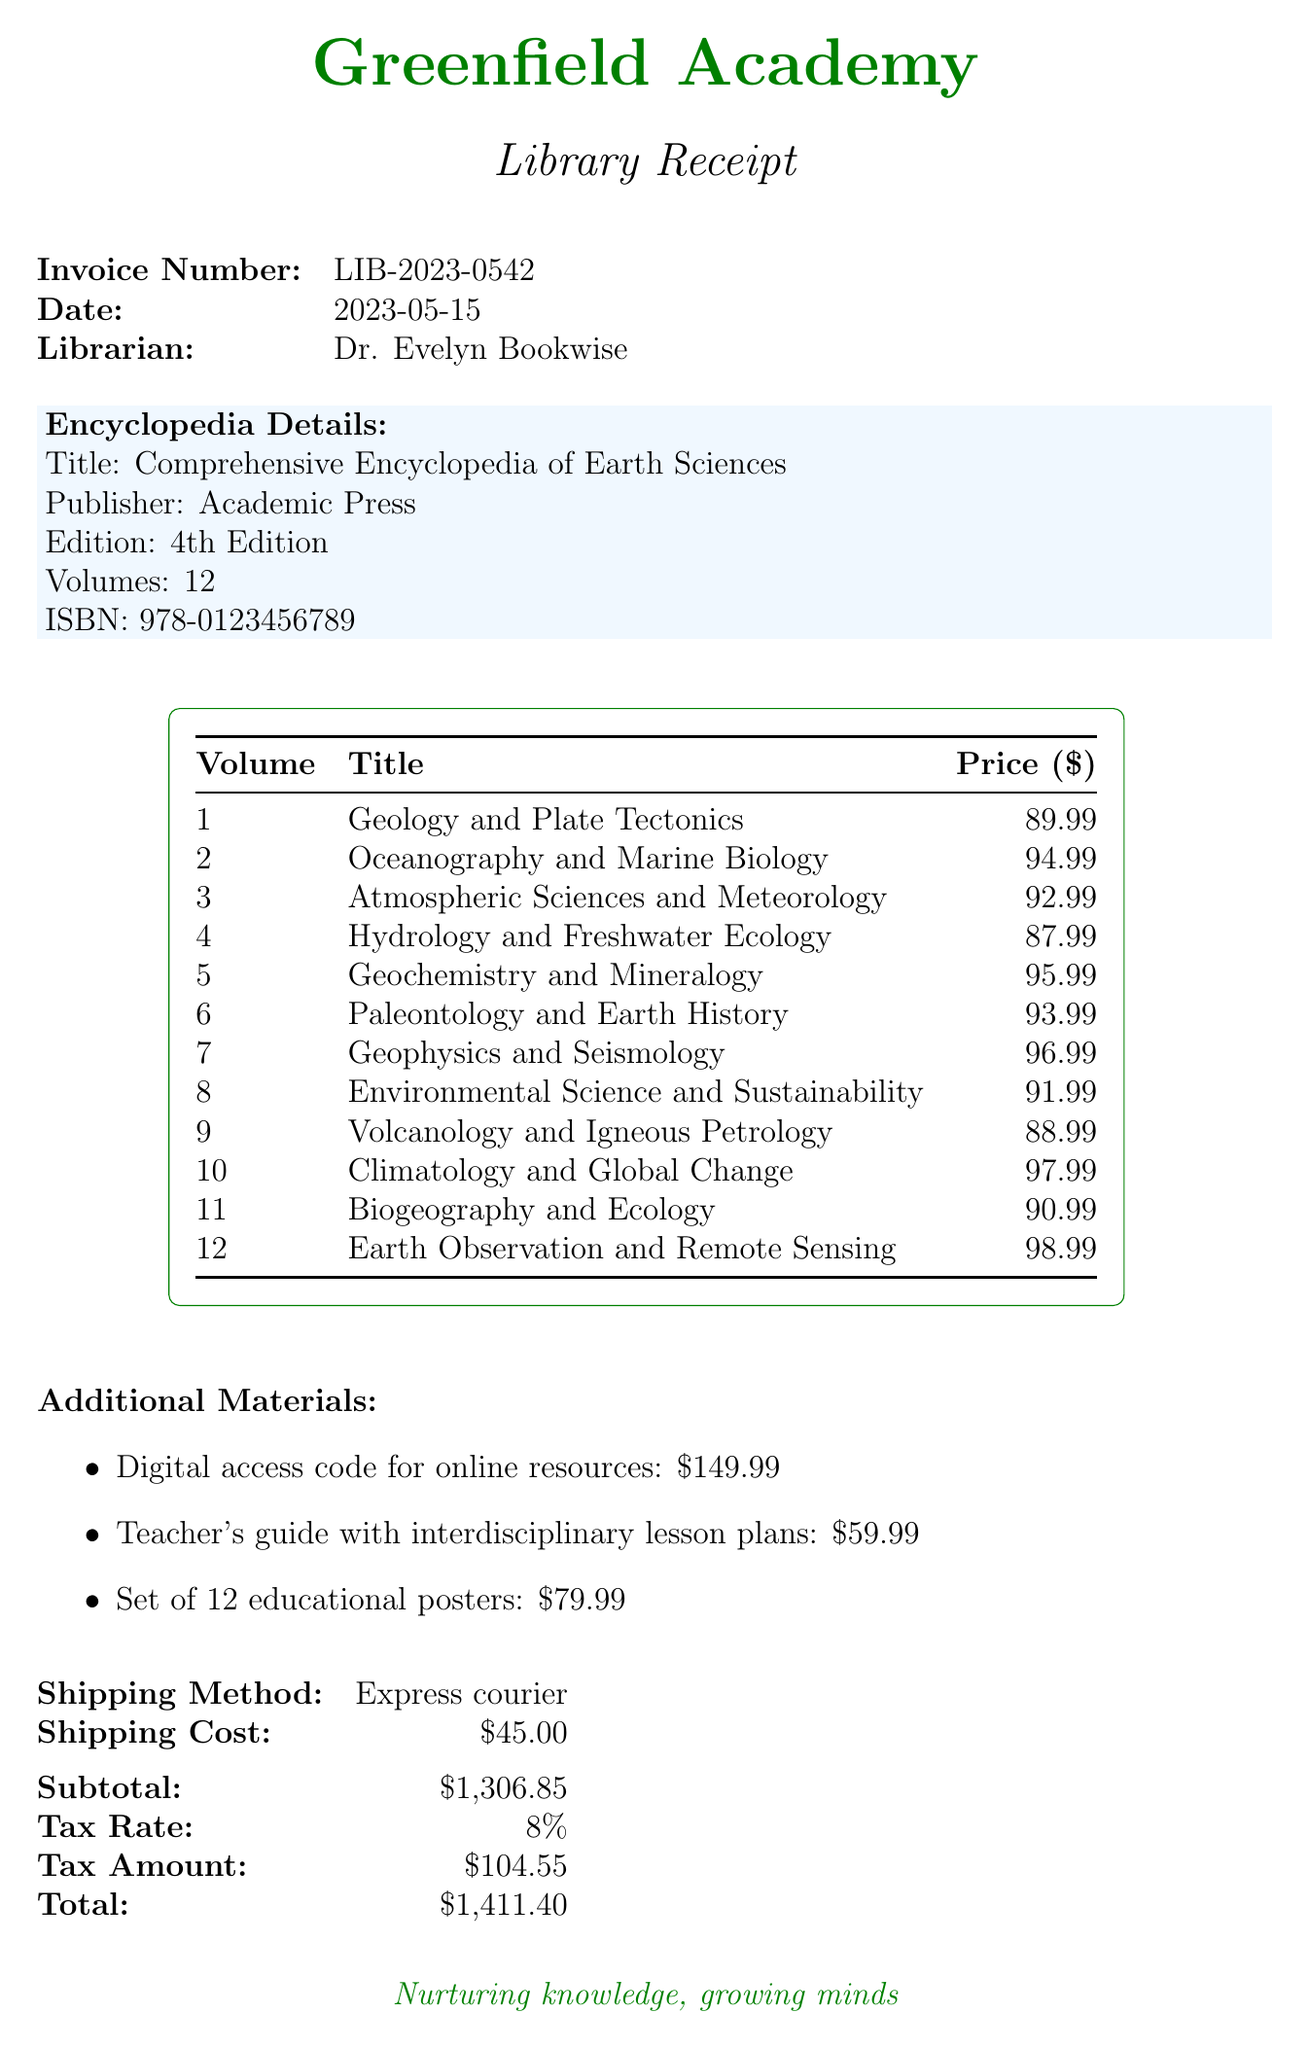what is the invoice number? The invoice number is listed at the top of the document.
Answer: LIB-2023-0542 what is the date of the invoice? The date is provided below the invoice number.
Answer: 2023-05-15 who is the librarian? The librarian's name appears in the receipt under "Librarian."
Answer: Dr. Evelyn Bookwise how many volumes are in the encyclopedia? The number of volumes is stated in the encyclopedia details section.
Answer: 12 what is the total amount due? The total amount is calculated and stated in the financial summary part of the document.
Answer: $1,411.40 what is the price of the 3rd volume? The price of each volume is listed in the price table.
Answer: $92.99 what additional material has the highest price? The additional materials' prices are listed; the highest one can be identified.
Answer: Digital access code for online resources what is the shipping method? The shipping method is provided in the shipping section.
Answer: Express courier how much did the tax amount to? The tax amount is detailed in the financial summary of the document.
Answer: $104.55 what is the purchase order number? The purchase order number is mentioned toward the end of the receipt.
Answer: PO-2023-0789 